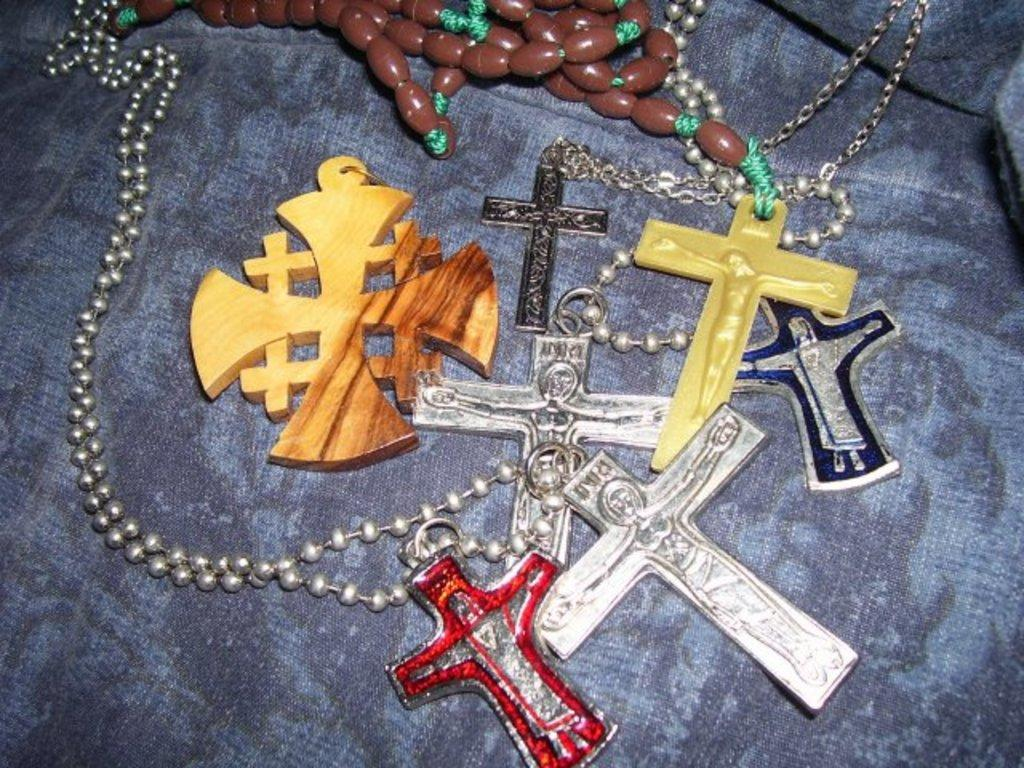What type of objects can be seen in the image? There are chains and pendants in the image. How are the chains and pendants arranged in the image? The chains and pendants are placed on a surface. Can you describe the relationship between the chains and pendants in the image? The chains are likely holding the pendants in place. How many cherries are on the board in the image? There are no cherries or boards present in the image. Can you describe the sink in the image? There is no sink present in the image. 